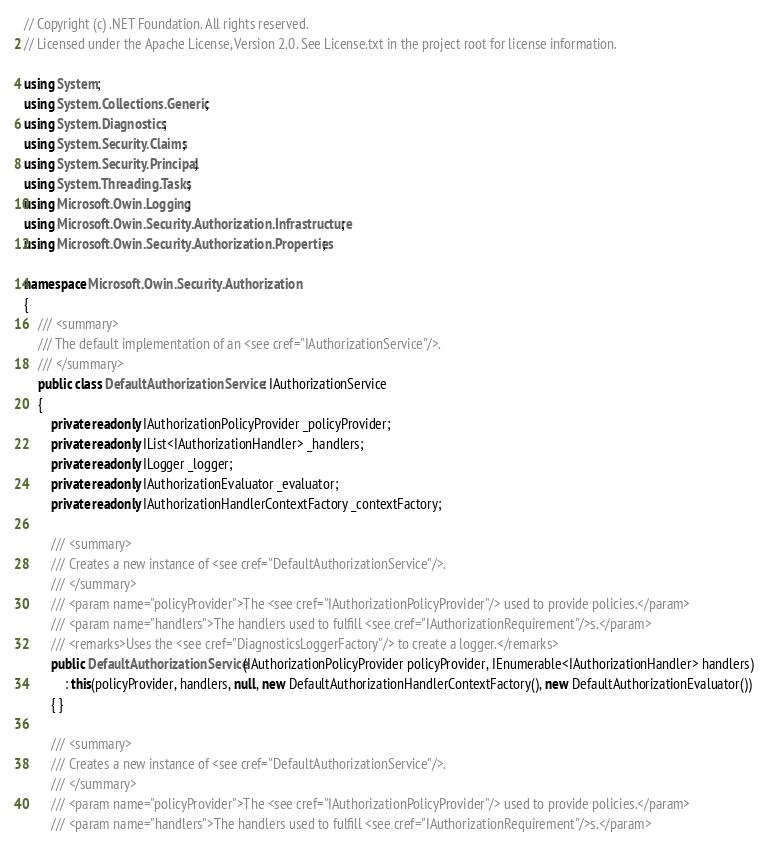<code> <loc_0><loc_0><loc_500><loc_500><_C#_>// Copyright (c) .NET Foundation. All rights reserved.
// Licensed under the Apache License, Version 2.0. See License.txt in the project root for license information.

using System;
using System.Collections.Generic;
using System.Diagnostics;
using System.Security.Claims;
using System.Security.Principal;
using System.Threading.Tasks;
using Microsoft.Owin.Logging;
using Microsoft.Owin.Security.Authorization.Infrastructure;
using Microsoft.Owin.Security.Authorization.Properties;

namespace Microsoft.Owin.Security.Authorization
{
    /// <summary>
    /// The default implementation of an <see cref="IAuthorizationService"/>.
    /// </summary>
    public class DefaultAuthorizationService : IAuthorizationService
    {
        private readonly IAuthorizationPolicyProvider _policyProvider;
        private readonly IList<IAuthorizationHandler> _handlers;
        private readonly ILogger _logger;
        private readonly IAuthorizationEvaluator _evaluator;
        private readonly IAuthorizationHandlerContextFactory _contextFactory;

        /// <summary>
        /// Creates a new instance of <see cref="DefaultAuthorizationService"/>.
        /// </summary>
        /// <param name="policyProvider">The <see cref="IAuthorizationPolicyProvider"/> used to provide policies.</param>
        /// <param name="handlers">The handlers used to fulfill <see cref="IAuthorizationRequirement"/>s.</param>
        /// <remarks>Uses the <see cref="DiagnosticsLoggerFactory"/> to create a logger.</remarks>
        public DefaultAuthorizationService(IAuthorizationPolicyProvider policyProvider, IEnumerable<IAuthorizationHandler> handlers) 
            : this(policyProvider, handlers, null, new DefaultAuthorizationHandlerContextFactory(), new DefaultAuthorizationEvaluator())
        { }

        /// <summary>
        /// Creates a new instance of <see cref="DefaultAuthorizationService"/>.
        /// </summary>
        /// <param name="policyProvider">The <see cref="IAuthorizationPolicyProvider"/> used to provide policies.</param>
        /// <param name="handlers">The handlers used to fulfill <see cref="IAuthorizationRequirement"/>s.</param></code> 